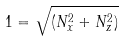Convert formula to latex. <formula><loc_0><loc_0><loc_500><loc_500>1 = \sqrt { ( N _ { x } ^ { 2 } + N _ { z } ^ { 2 } ) }</formula> 